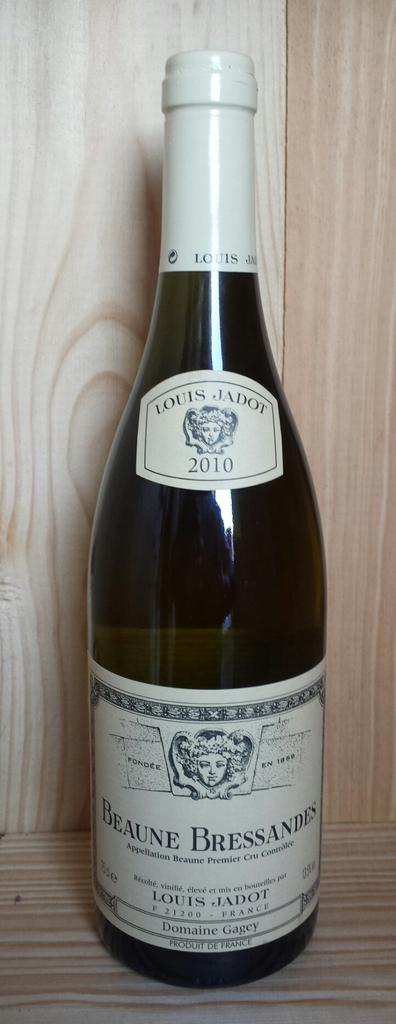Provide a one-sentence caption for the provided image. A bottle of wine from 2010 has a label that indicates it was made by Louis Jadot. 